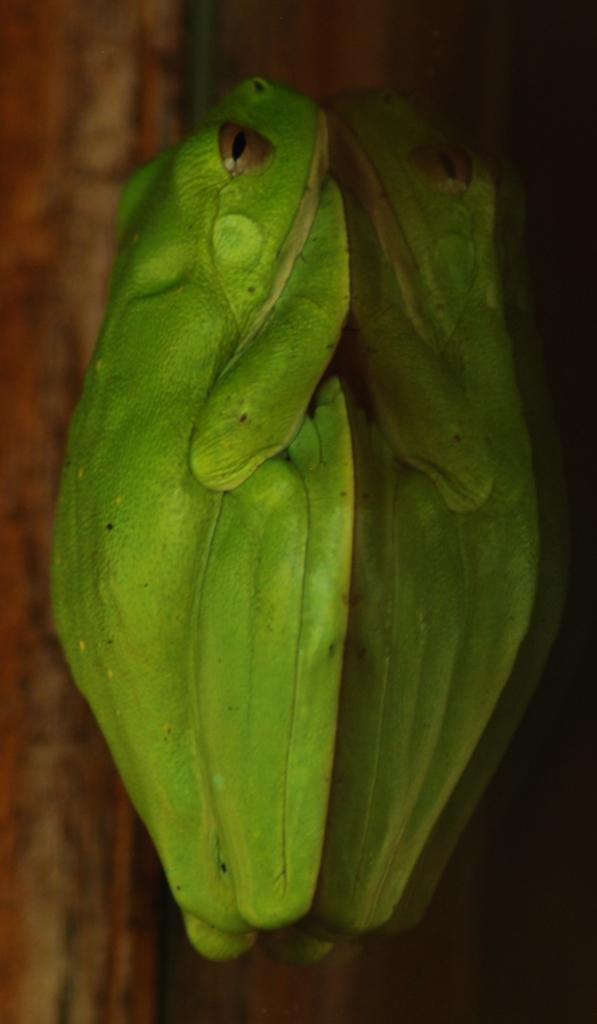What type of animal is in the image? There is a frog in the image. What is the frog sitting on in the image? The frog is on a glass surface. Are there any fairies interacting with the frog in the image? No, there are no fairies present in the image. What is the frog's digestive system like in the image? The image does not provide any information about the frog's digestive system. 